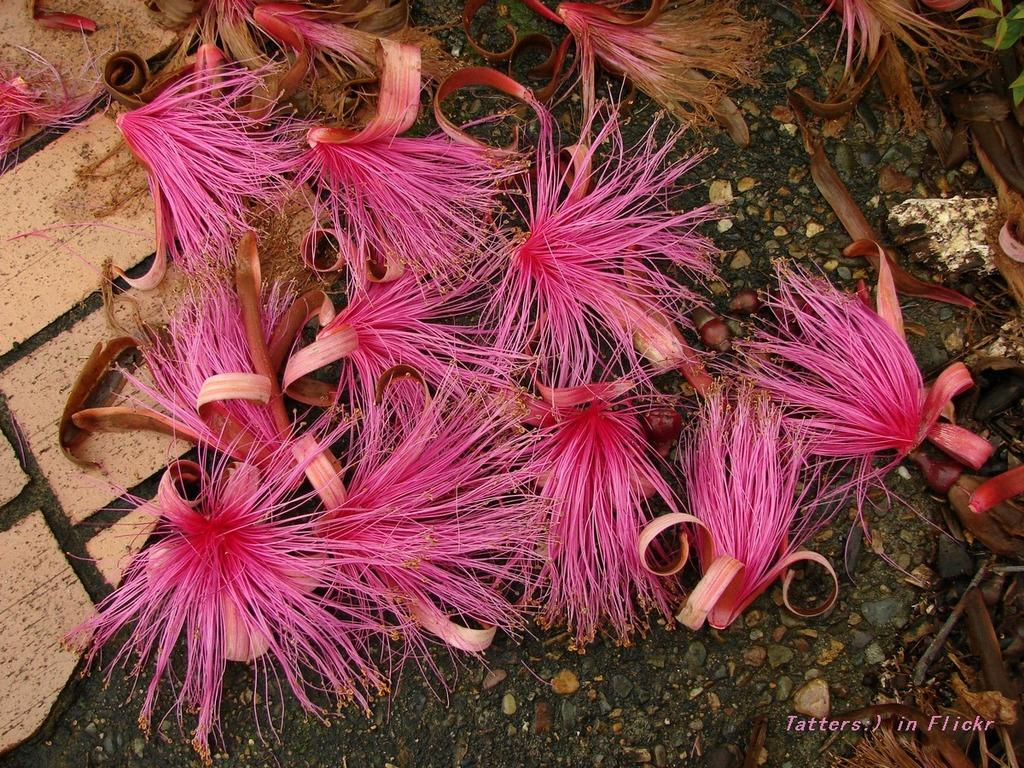What type of plants can be seen in the image? There are flowers in the image. What color are the flowers? The flowers are pink. What can be seen beneath the flowers in the image? There is soil visible in the image. What other objects are present in the image? There are stones in the image. What is on the left side of the image? There is a pavement on the left side of the image. What type of book can be seen on the pavement in the image? There is no book present in the image; it only features flowers, soil, stones, and a pavement. What kind of pickle is being used to water the flowers in the image? There is no pickle present in the image, and pickles are not used for watering plants. 